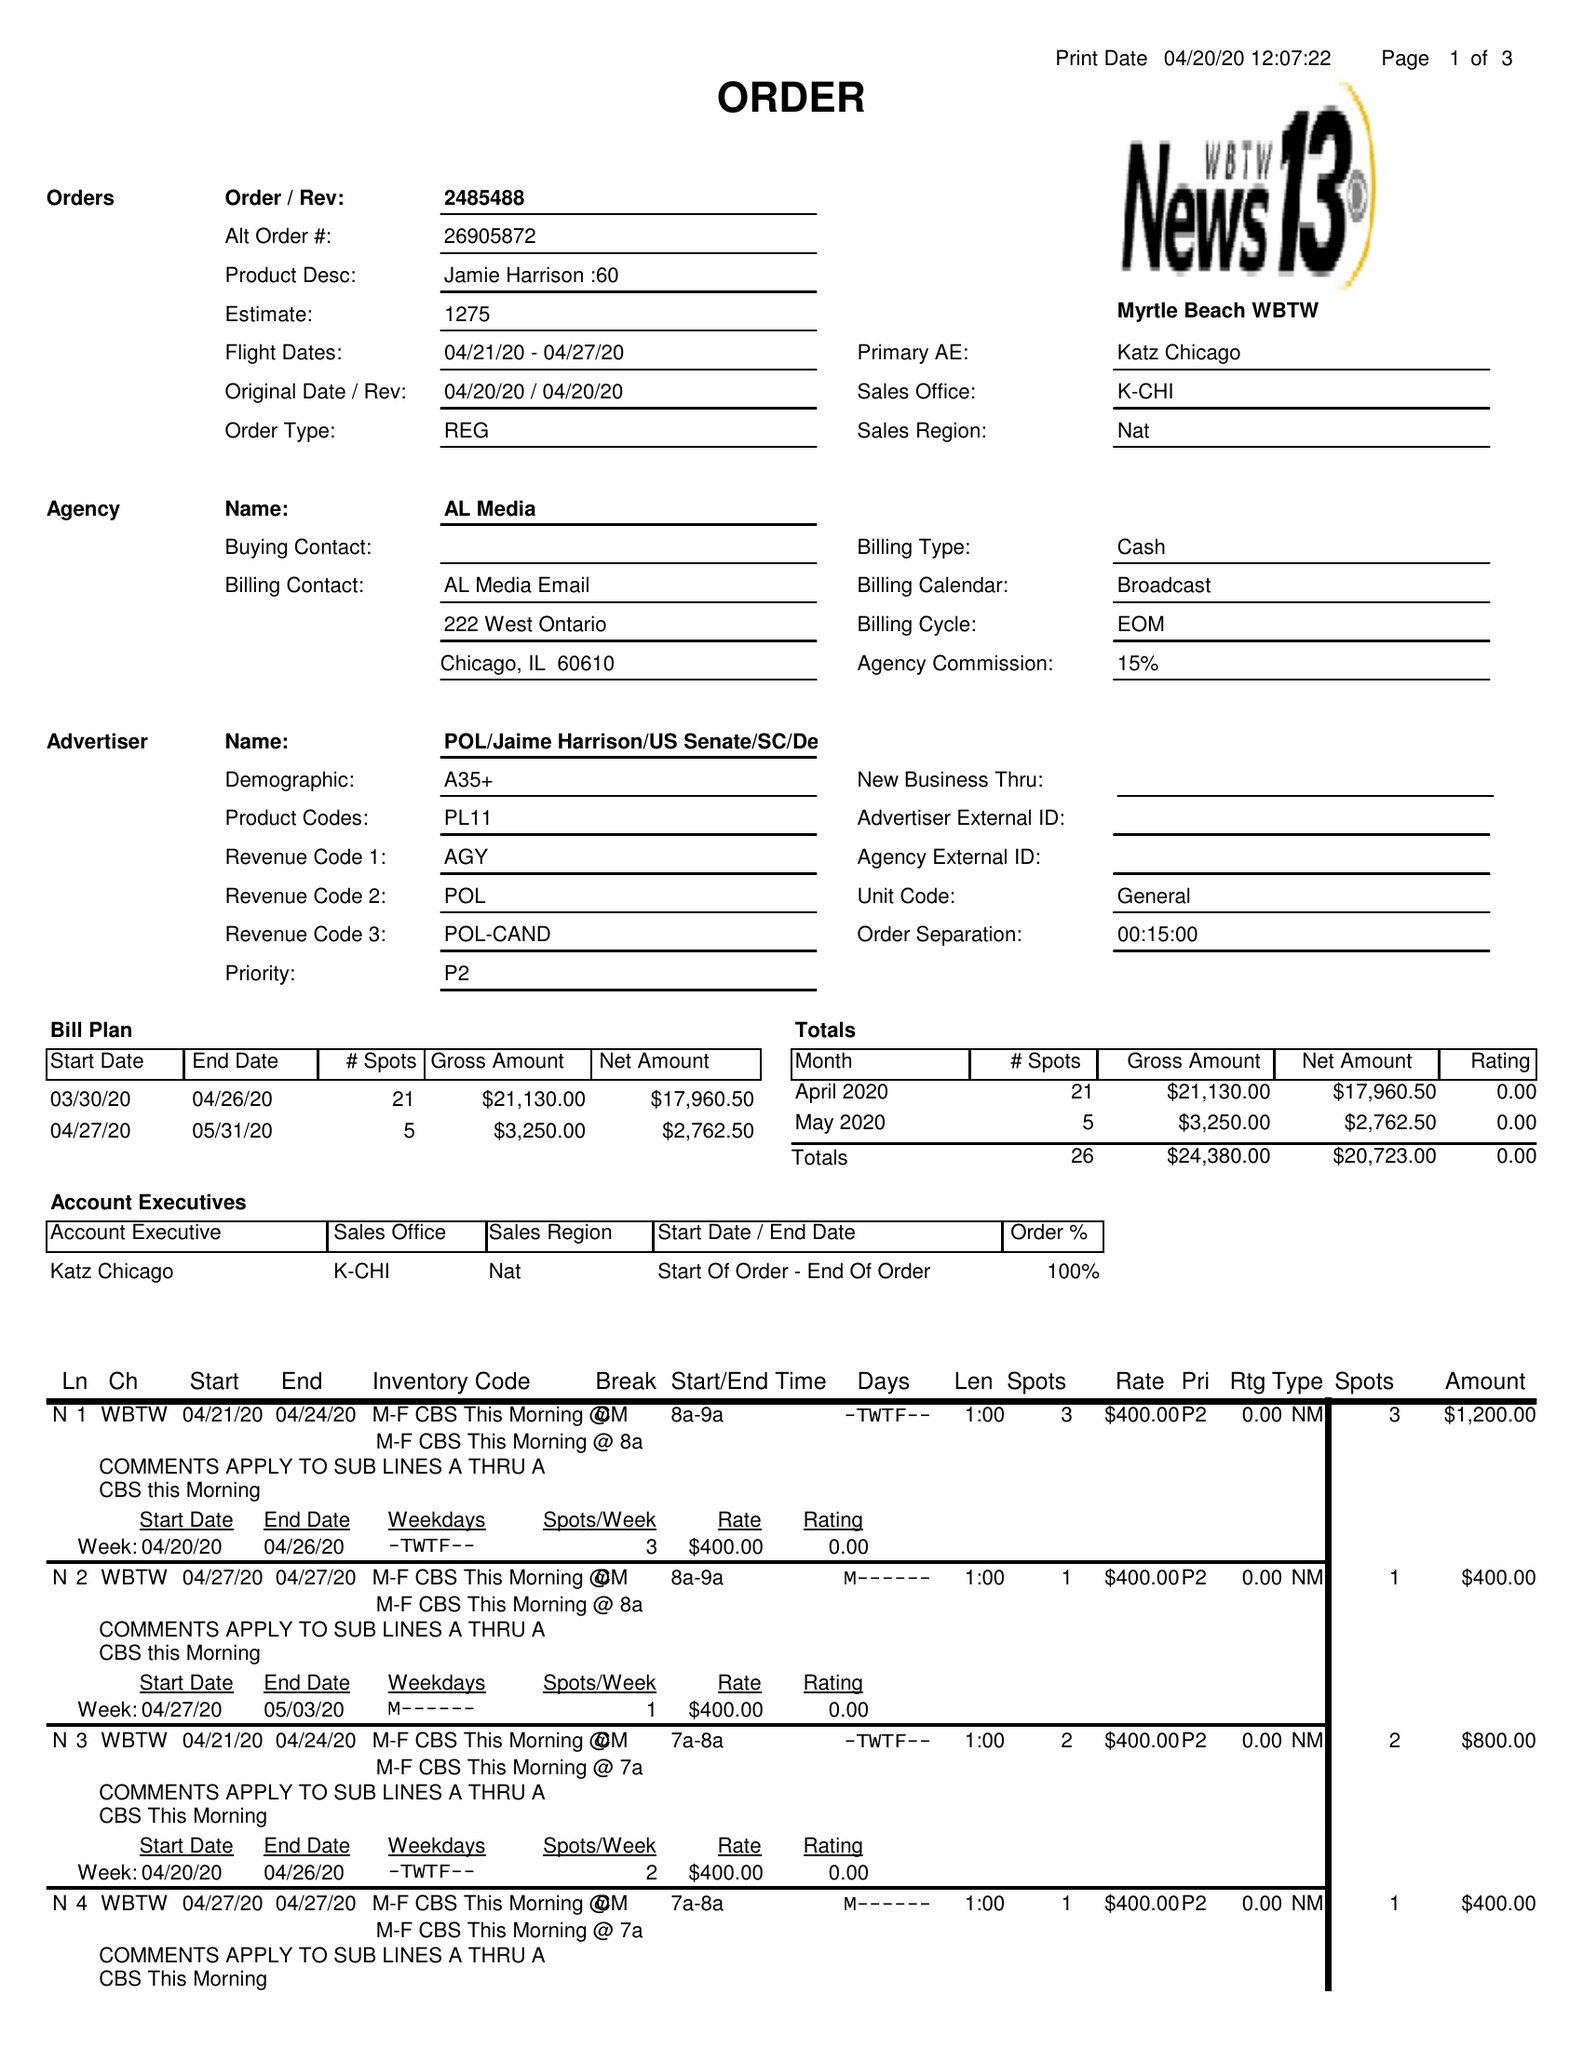What is the value for the contract_num?
Answer the question using a single word or phrase. 2485488 